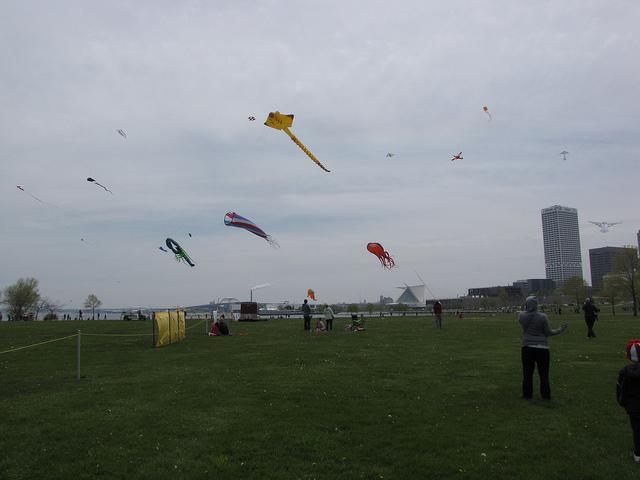How many kites are in the sky?
Write a very short answer. 16. Is it a windy day?
Quick response, please. Yes. What prevents cars from driving onto the field?
Keep it brief. Fence. Is it a sunny day?
Keep it brief. No. Is it overcast?
Be succinct. Yes. Are these kites elaborate?
Write a very short answer. Yes. Which direction is the wind blowing?
Answer briefly. Left. Can all women do this?
Keep it brief. Yes. What color is the sky?
Answer briefly. Gray. What are the flying?
Answer briefly. Kites. 